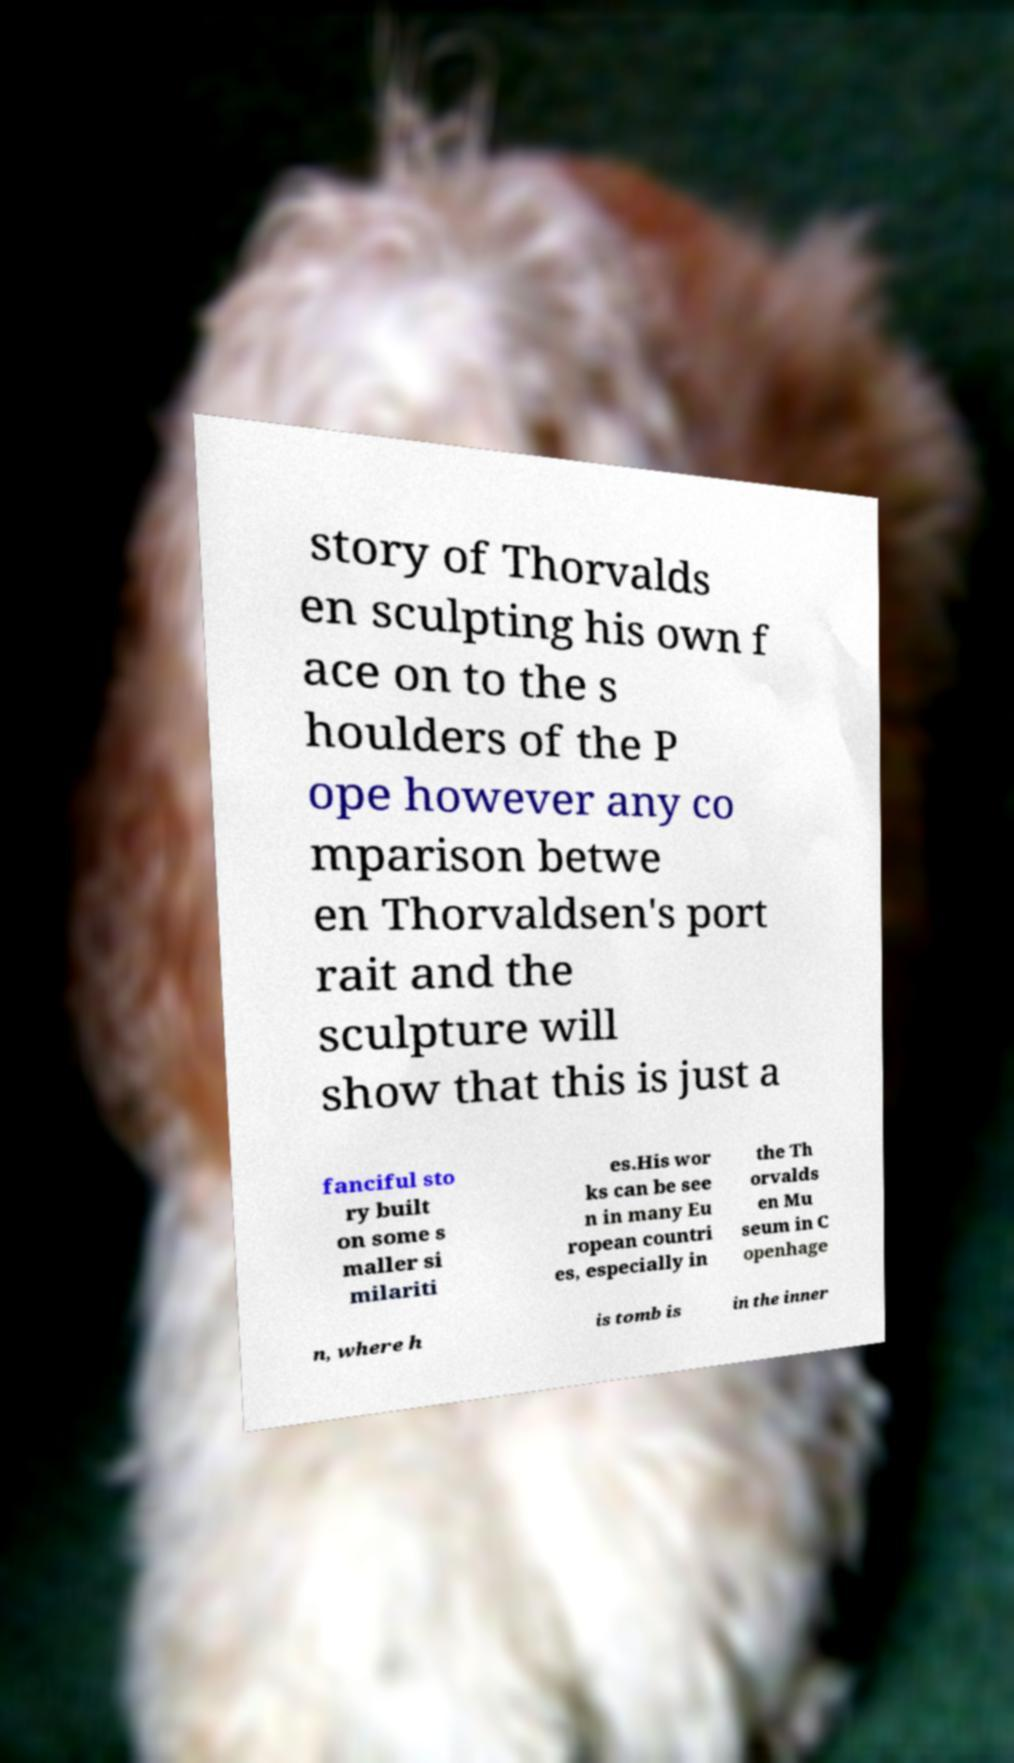Please read and relay the text visible in this image. What does it say? story of Thorvalds en sculpting his own f ace on to the s houlders of the P ope however any co mparison betwe en Thorvaldsen's port rait and the sculpture will show that this is just a fanciful sto ry built on some s maller si milariti es.His wor ks can be see n in many Eu ropean countri es, especially in the Th orvalds en Mu seum in C openhage n, where h is tomb is in the inner 